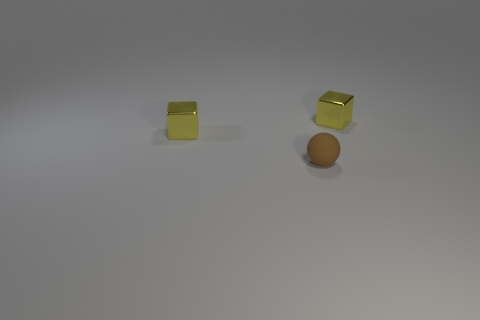There is a small brown thing; how many tiny spheres are behind it? 0 